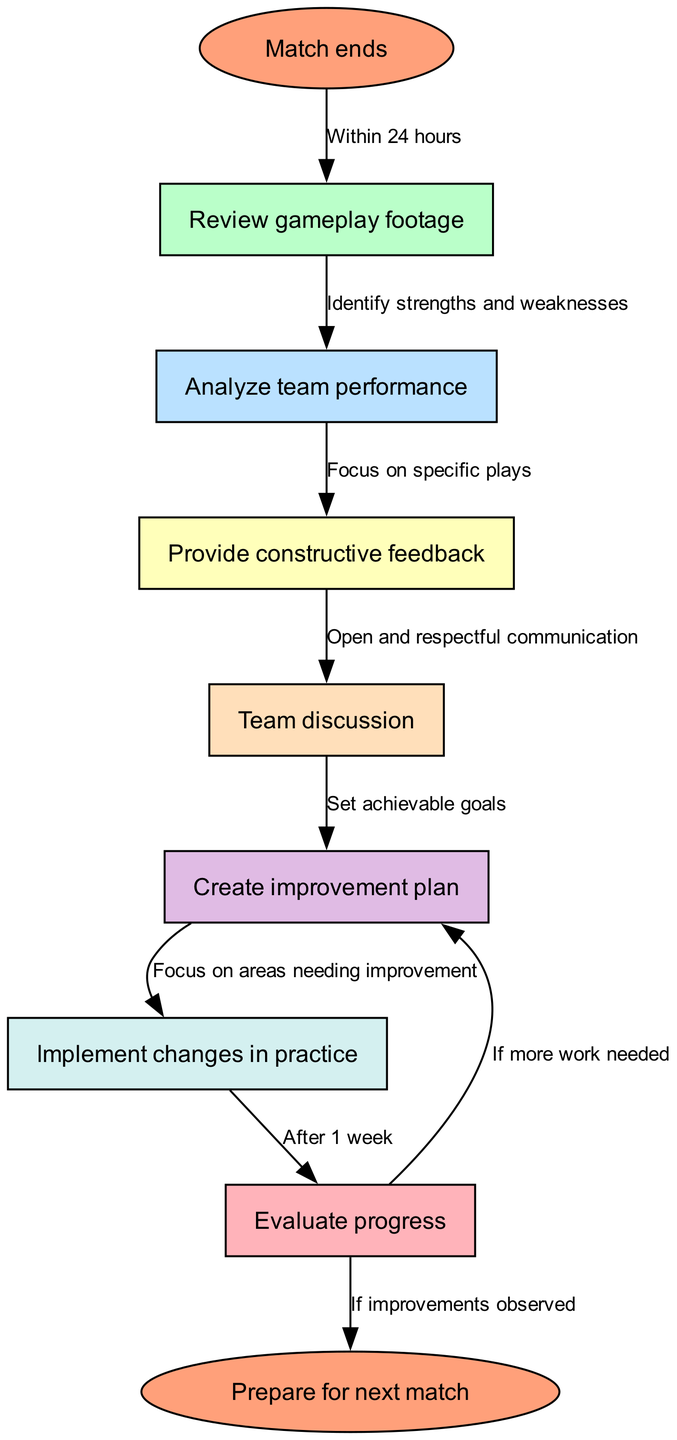What is the first step after a match ends? According to the flowchart, the first step after a match ends is to "Review gameplay footage". This is the direct next node following "Match ends".
Answer: Review gameplay footage How many nodes are in the diagram? The diagram contains 9 nodes in total, representing different steps in the workflow from the beginning to the end. Count each distinct step in the diagram.
Answer: 9 What follows the "Discuss" node? After the "Discuss" node, the next step is to "Create improvement plan". This is a direct connection outlined in the edges of the flowchart.
Answer: Create improvement plan What should be done if improvements are observed? If improvements are observed after evaluation, the flowchart indicates that the next step is to "Prepare for next match". This follows the evaluation of progress.
Answer: Prepare for next match What is the purpose of the "Analyze team performance" step? The purpose of the "Analyze team performance" step is to "Focus on specific plays". It serves as a basis for providing feedback and reviewing team strengths and weaknesses.
Answer: Focus on specific plays What is the outcome if more work is needed after evaluation? If more work is needed after evaluation, the workflow leads back to "Create improvement plan". This indicates the necessity for continued effort in areas identified during evaluation.
Answer: Create improvement plan What type of communication is emphasized in the "Provide constructive feedback" step? The flowchart emphasizes "Open and respectful communication" in the "Provide constructive feedback" step, highlighting the importance of a positive interaction among team members.
Answer: Open and respectful communication After how long should progress be evaluated in practice? Progress should be evaluated after "1 week" of implementing changes in practice, as stated in the edge connecting these two steps in the flowchart.
Answer: 1 week 